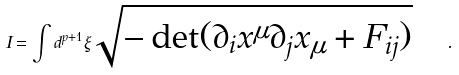Convert formula to latex. <formula><loc_0><loc_0><loc_500><loc_500>I = \int d ^ { p + 1 } \xi \sqrt { - \det ( \partial _ { i } x ^ { \mu } \partial _ { j } x _ { \mu } + F _ { i j } ) } \quad .</formula> 